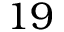Convert formula to latex. <formula><loc_0><loc_0><loc_500><loc_500>1 9</formula> 